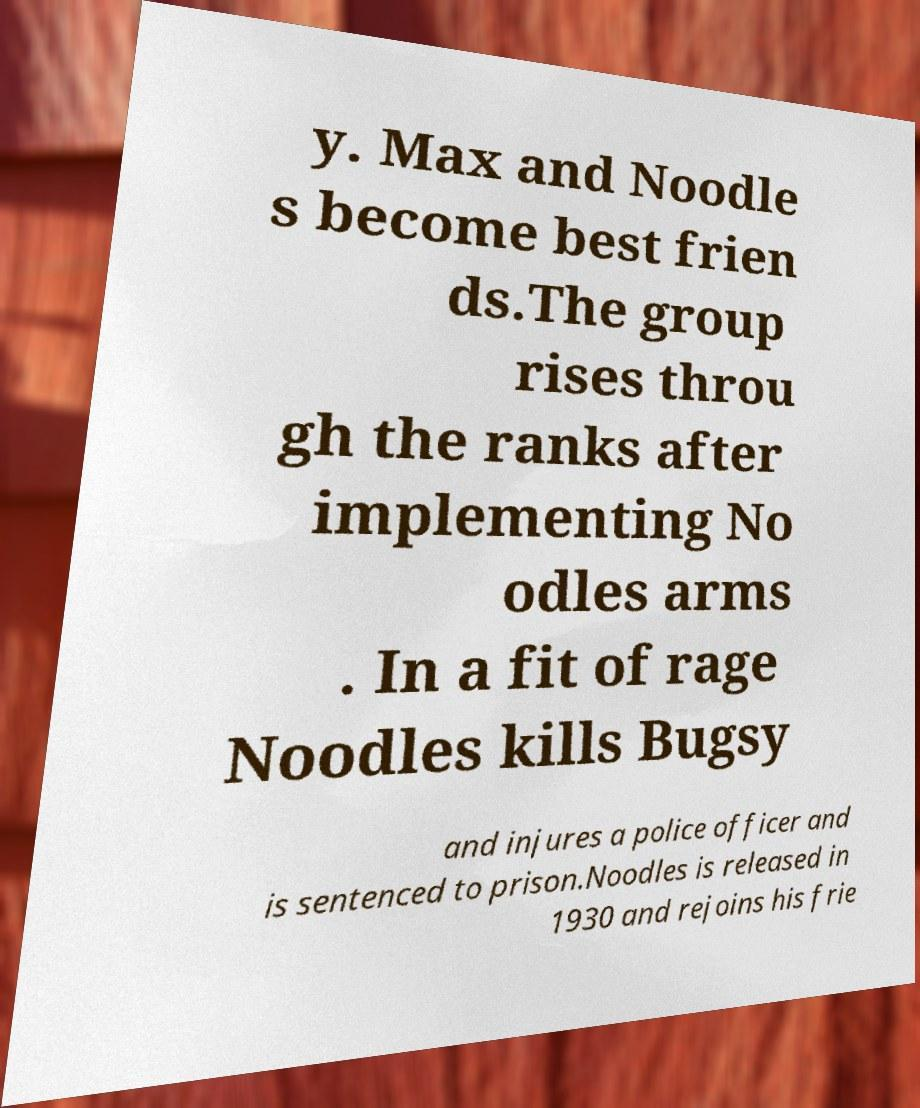Can you accurately transcribe the text from the provided image for me? y. Max and Noodle s become best frien ds.The group rises throu gh the ranks after implementing No odles arms . In a fit of rage Noodles kills Bugsy and injures a police officer and is sentenced to prison.Noodles is released in 1930 and rejoins his frie 